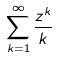Convert formula to latex. <formula><loc_0><loc_0><loc_500><loc_500>\sum _ { k = 1 } ^ { \infty } \frac { z ^ { k } } { k }</formula> 